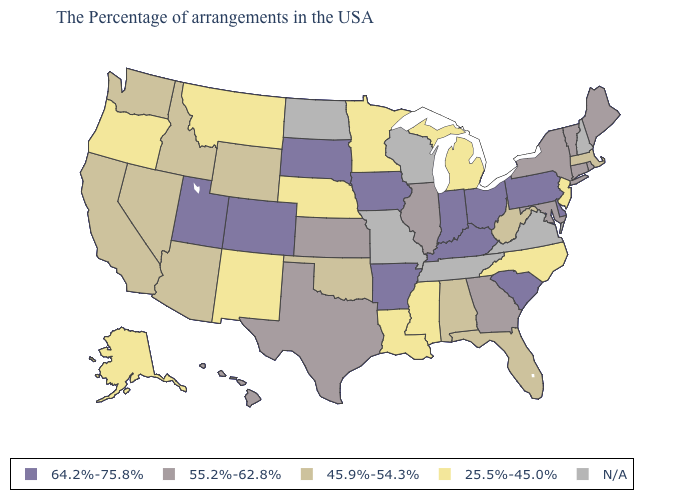What is the lowest value in the Northeast?
Quick response, please. 25.5%-45.0%. What is the highest value in the West ?
Be succinct. 64.2%-75.8%. What is the value of Texas?
Be succinct. 55.2%-62.8%. What is the value of Maine?
Concise answer only. 55.2%-62.8%. Does South Carolina have the highest value in the South?
Give a very brief answer. Yes. Name the states that have a value in the range 64.2%-75.8%?
Answer briefly. Delaware, Pennsylvania, South Carolina, Ohio, Kentucky, Indiana, Arkansas, Iowa, South Dakota, Colorado, Utah. Does the map have missing data?
Concise answer only. Yes. What is the highest value in the MidWest ?
Give a very brief answer. 64.2%-75.8%. Does New Jersey have the lowest value in the Northeast?
Short answer required. Yes. What is the value of Nevada?
Short answer required. 45.9%-54.3%. Does New Mexico have the lowest value in the West?
Short answer required. Yes. Does the map have missing data?
Give a very brief answer. Yes. Does the first symbol in the legend represent the smallest category?
Be succinct. No. How many symbols are there in the legend?
Quick response, please. 5. 